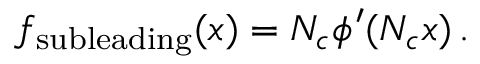Convert formula to latex. <formula><loc_0><loc_0><loc_500><loc_500>f _ { s u b l e a d i n g } ( x ) = N _ { c } \phi ^ { \prime } ( N _ { c } x ) \, .</formula> 